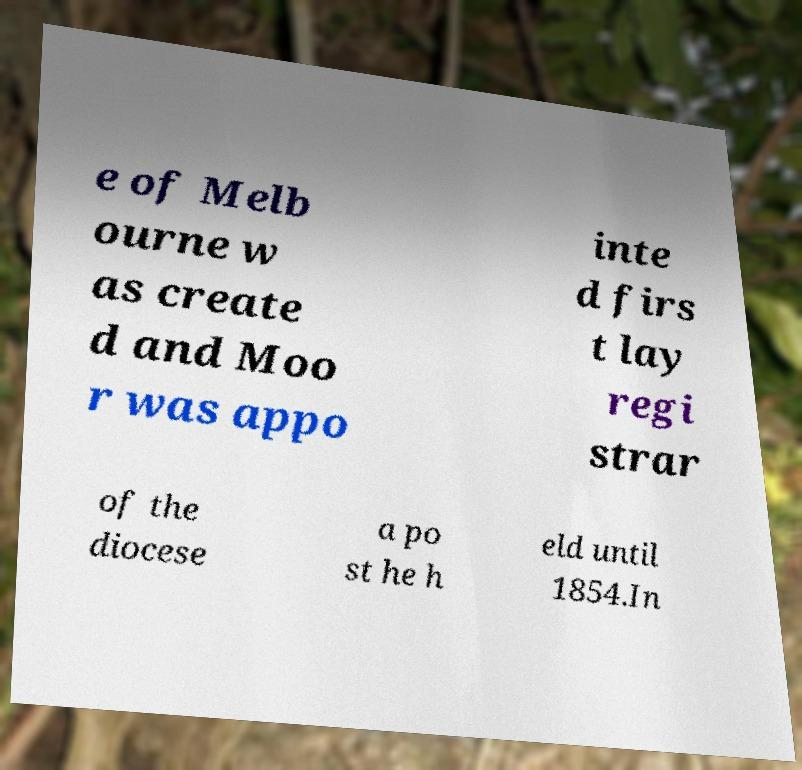Could you extract and type out the text from this image? e of Melb ourne w as create d and Moo r was appo inte d firs t lay regi strar of the diocese a po st he h eld until 1854.In 